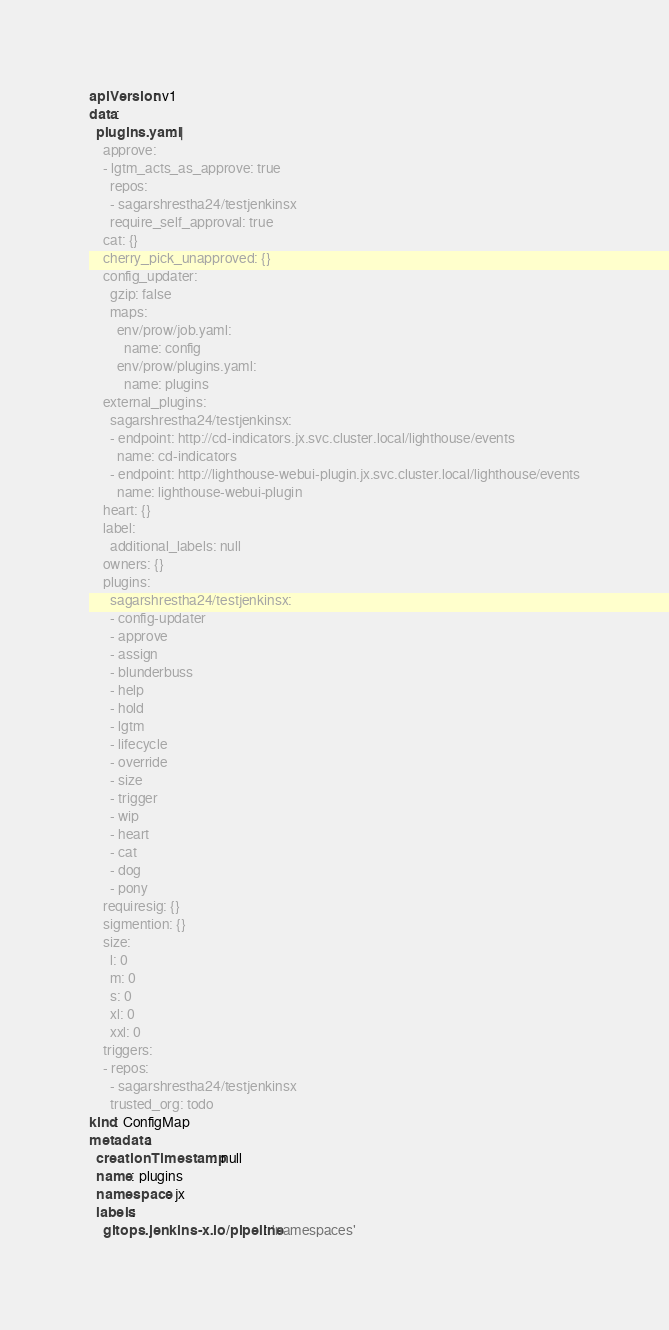Convert code to text. <code><loc_0><loc_0><loc_500><loc_500><_YAML_>apiVersion: v1
data:
  plugins.yaml: |
    approve:
    - lgtm_acts_as_approve: true
      repos:
      - sagarshrestha24/testjenkinsx
      require_self_approval: true
    cat: {}
    cherry_pick_unapproved: {}
    config_updater:
      gzip: false
      maps:
        env/prow/job.yaml:
          name: config
        env/prow/plugins.yaml:
          name: plugins
    external_plugins:
      sagarshrestha24/testjenkinsx:
      - endpoint: http://cd-indicators.jx.svc.cluster.local/lighthouse/events
        name: cd-indicators
      - endpoint: http://lighthouse-webui-plugin.jx.svc.cluster.local/lighthouse/events
        name: lighthouse-webui-plugin
    heart: {}
    label:
      additional_labels: null
    owners: {}
    plugins:
      sagarshrestha24/testjenkinsx:
      - config-updater
      - approve
      - assign
      - blunderbuss
      - help
      - hold
      - lgtm
      - lifecycle
      - override
      - size
      - trigger
      - wip
      - heart
      - cat
      - dog
      - pony
    requiresig: {}
    sigmention: {}
    size:
      l: 0
      m: 0
      s: 0
      xl: 0
      xxl: 0
    triggers:
    - repos:
      - sagarshrestha24/testjenkinsx
      trusted_org: todo
kind: ConfigMap
metadata:
  creationTimestamp: null
  name: plugins
  namespace: jx
  labels:
    gitops.jenkins-x.io/pipeline: 'namespaces'
</code> 